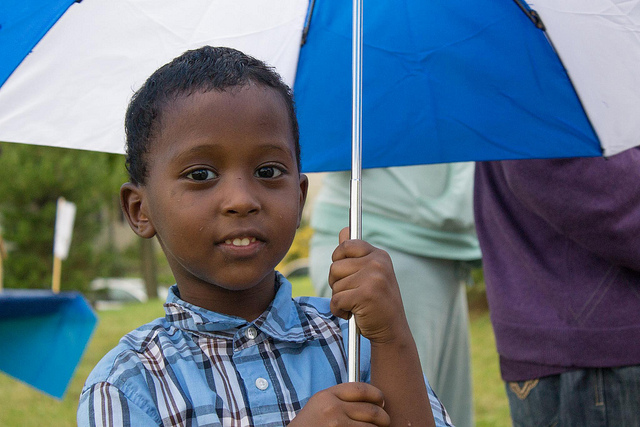<image>Is the child going to be a doctor? It is unknown if the child is going to be a doctor. Is the child going to be a doctor? I am not sure if the child is going to be a doctor. It can be both yes, no or unknown. 